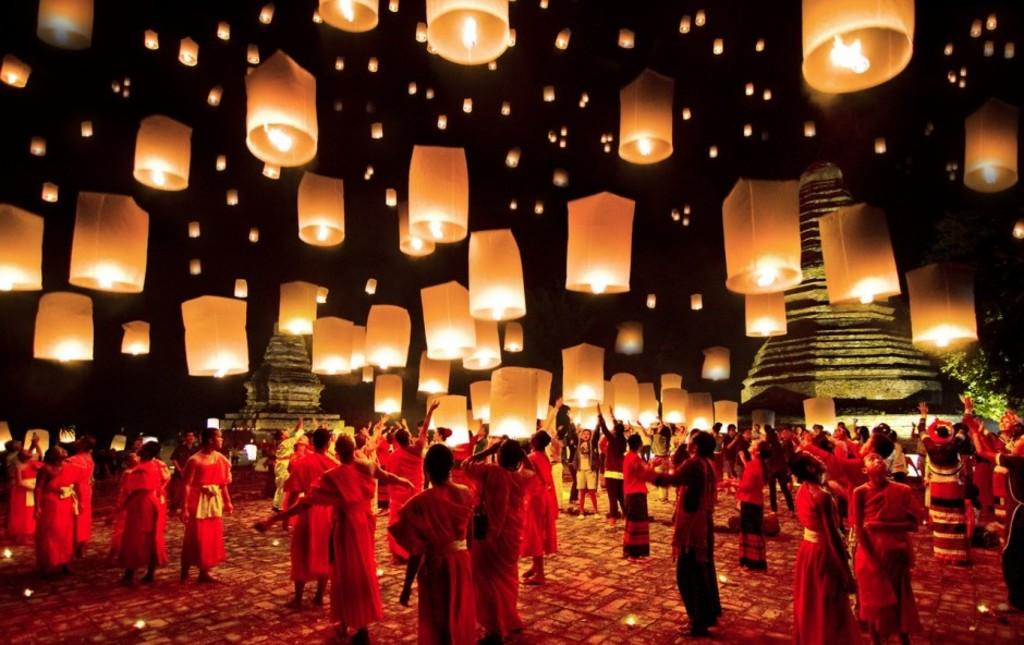How many people are in the group visible in the image? There is a group of people in the image, but the exact number is not specified. What type of decorations are present in the image? There are paper lanterns in the image. What can be seen in the distance in the image? There are buildings and trees in the background of the image. What is the mass of the frame surrounding the image? There is no frame surrounding the image, as it is a photograph or digital representation. 